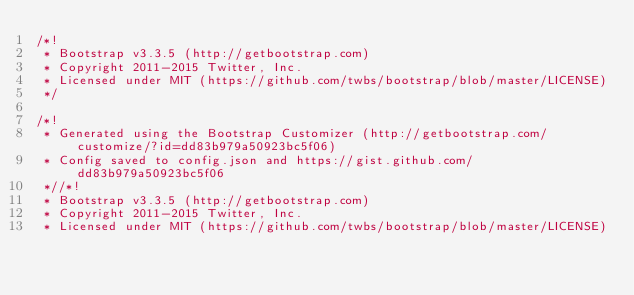Convert code to text. <code><loc_0><loc_0><loc_500><loc_500><_CSS_>/*!
 * Bootstrap v3.3.5 (http://getbootstrap.com)
 * Copyright 2011-2015 Twitter, Inc.
 * Licensed under MIT (https://github.com/twbs/bootstrap/blob/master/LICENSE)
 */

/*!
 * Generated using the Bootstrap Customizer (http://getbootstrap.com/customize/?id=dd83b979a50923bc5f06)
 * Config saved to config.json and https://gist.github.com/dd83b979a50923bc5f06
 *//*!
 * Bootstrap v3.3.5 (http://getbootstrap.com)
 * Copyright 2011-2015 Twitter, Inc.
 * Licensed under MIT (https://github.com/twbs/bootstrap/blob/master/LICENSE)</code> 